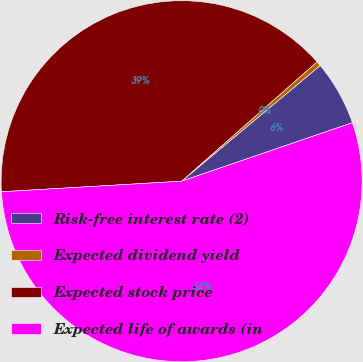<chart> <loc_0><loc_0><loc_500><loc_500><pie_chart><fcel>Risk-free interest rate (2)<fcel>Expected dividend yield<fcel>Expected stock price<fcel>Expected life of awards (in<nl><fcel>5.82%<fcel>0.43%<fcel>39.43%<fcel>54.31%<nl></chart> 